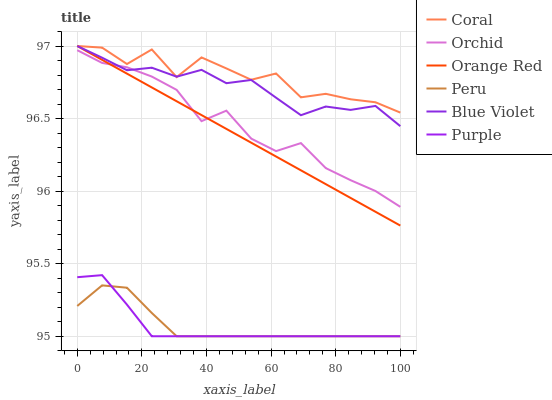Does Peru have the minimum area under the curve?
Answer yes or no. No. Does Peru have the maximum area under the curve?
Answer yes or no. No. Is Peru the smoothest?
Answer yes or no. No. Is Peru the roughest?
Answer yes or no. No. Does Coral have the lowest value?
Answer yes or no. No. Does Peru have the highest value?
Answer yes or no. No. Is Purple less than Orange Red?
Answer yes or no. Yes. Is Coral greater than Peru?
Answer yes or no. Yes. Does Purple intersect Orange Red?
Answer yes or no. No. 